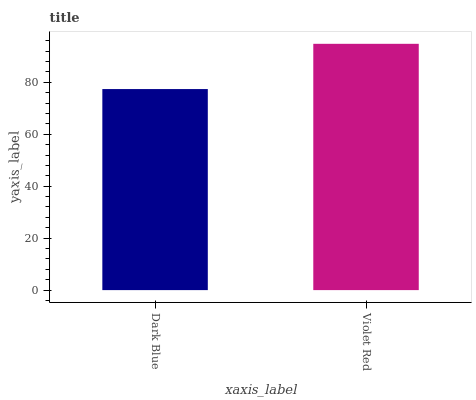Is Violet Red the minimum?
Answer yes or no. No. Is Violet Red greater than Dark Blue?
Answer yes or no. Yes. Is Dark Blue less than Violet Red?
Answer yes or no. Yes. Is Dark Blue greater than Violet Red?
Answer yes or no. No. Is Violet Red less than Dark Blue?
Answer yes or no. No. Is Violet Red the high median?
Answer yes or no. Yes. Is Dark Blue the low median?
Answer yes or no. Yes. Is Dark Blue the high median?
Answer yes or no. No. Is Violet Red the low median?
Answer yes or no. No. 